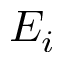<formula> <loc_0><loc_0><loc_500><loc_500>E _ { i }</formula> 